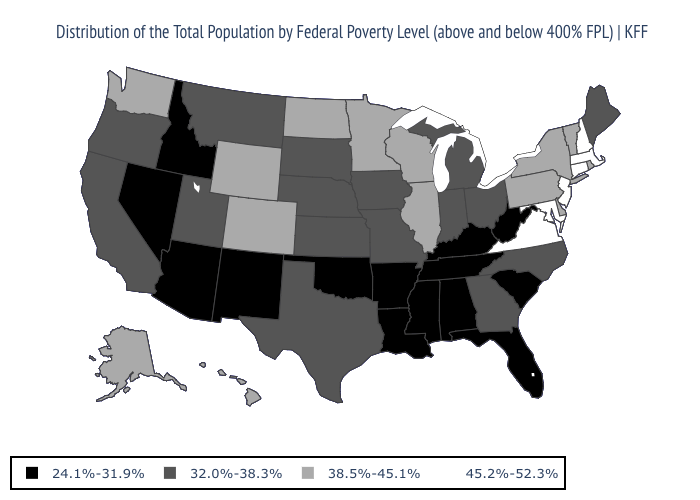Name the states that have a value in the range 45.2%-52.3%?
Be succinct. Connecticut, Maryland, Massachusetts, New Hampshire, New Jersey, Virginia. What is the value of Arizona?
Answer briefly. 24.1%-31.9%. What is the value of North Carolina?
Quick response, please. 32.0%-38.3%. Among the states that border Washington , does Oregon have the lowest value?
Concise answer only. No. Among the states that border Kentucky , which have the highest value?
Be succinct. Virginia. Does the map have missing data?
Quick response, please. No. Does Mississippi have the lowest value in the USA?
Concise answer only. Yes. Name the states that have a value in the range 45.2%-52.3%?
Concise answer only. Connecticut, Maryland, Massachusetts, New Hampshire, New Jersey, Virginia. Which states have the lowest value in the USA?
Concise answer only. Alabama, Arizona, Arkansas, Florida, Idaho, Kentucky, Louisiana, Mississippi, Nevada, New Mexico, Oklahoma, South Carolina, Tennessee, West Virginia. Does Oklahoma have the same value as Nebraska?
Short answer required. No. Name the states that have a value in the range 38.5%-45.1%?
Be succinct. Alaska, Colorado, Delaware, Hawaii, Illinois, Minnesota, New York, North Dakota, Pennsylvania, Rhode Island, Vermont, Washington, Wisconsin, Wyoming. What is the value of Nevada?
Short answer required. 24.1%-31.9%. Does Virginia have the lowest value in the South?
Give a very brief answer. No. What is the lowest value in the MidWest?
Be succinct. 32.0%-38.3%. Name the states that have a value in the range 45.2%-52.3%?
Answer briefly. Connecticut, Maryland, Massachusetts, New Hampshire, New Jersey, Virginia. 